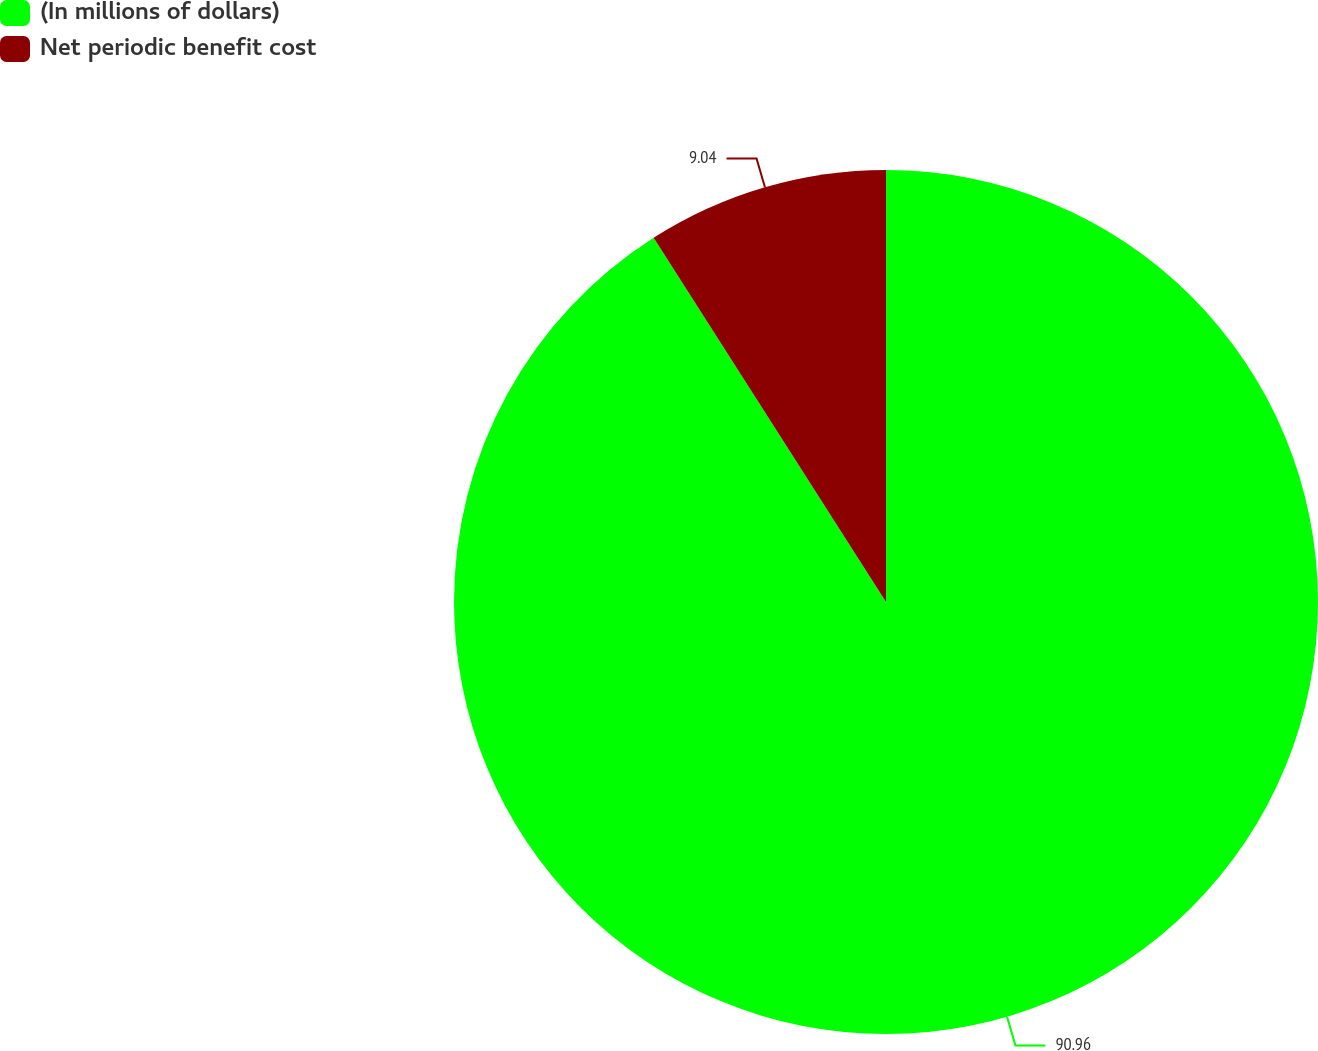Convert chart. <chart><loc_0><loc_0><loc_500><loc_500><pie_chart><fcel>(In millions of dollars)<fcel>Net periodic benefit cost<nl><fcel>90.96%<fcel>9.04%<nl></chart> 